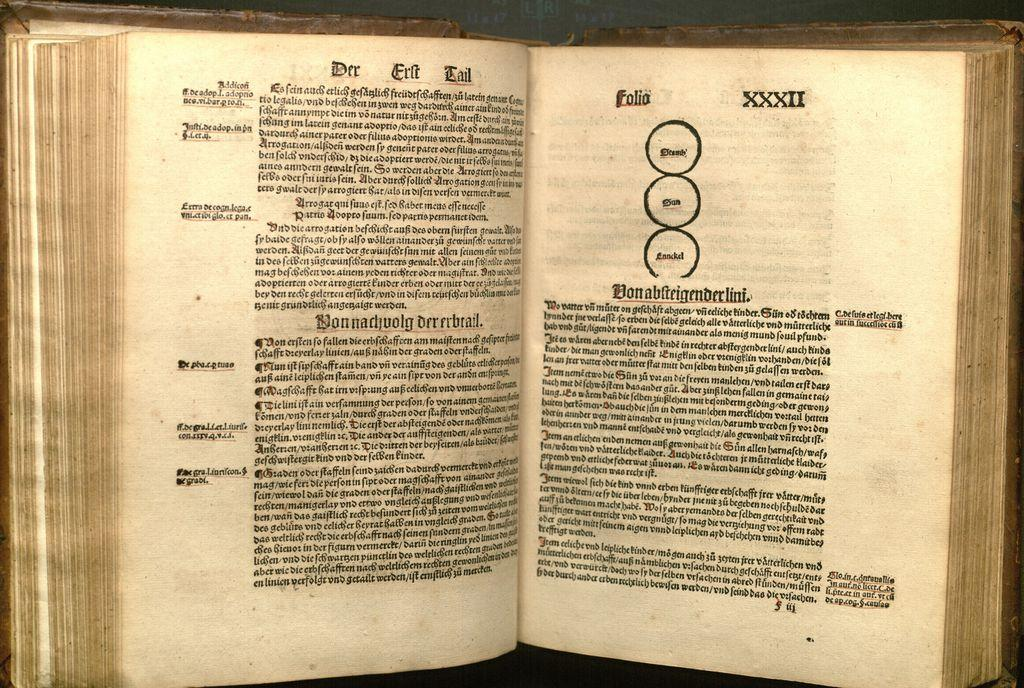<image>
Create a compact narrative representing the image presented. An open book with the left page title being Der Erlt Tail 